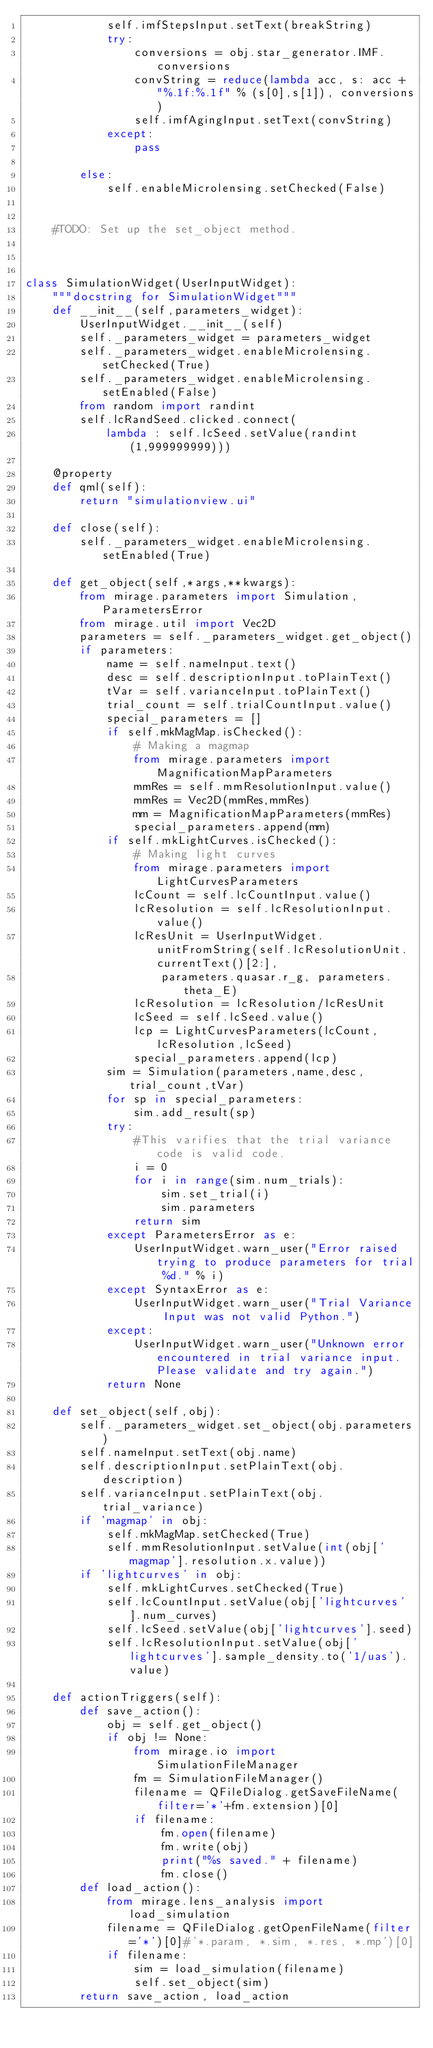Convert code to text. <code><loc_0><loc_0><loc_500><loc_500><_Python_>            self.imfStepsInput.setText(breakString)
            try:
                conversions = obj.star_generator.IMF.conversions
                convString = reduce(lambda acc, s: acc + "%.1f:%.1f" % (s[0],s[1]), conversions)
                self.imfAgingInput.setText(convString)
            except:
                pass

        else:
            self.enableMicrolensing.setChecked(False)


    #TODO: Set up the set_object method.



class SimulationWidget(UserInputWidget):
    """docstring for SimulationWidget"""
    def __init__(self,parameters_widget):
        UserInputWidget.__init__(self)
        self._parameters_widget = parameters_widget
        self._parameters_widget.enableMicrolensing.setChecked(True)
        self._parameters_widget.enableMicrolensing.setEnabled(False)
        from random import randint
        self.lcRandSeed.clicked.connect(
            lambda : self.lcSeed.setValue(randint(1,999999999)))

    @property
    def qml(self):
        return "simulationview.ui"

    def close(self):
        self._parameters_widget.enableMicrolensing.setEnabled(True)

    def get_object(self,*args,**kwargs):
        from mirage.parameters import Simulation, ParametersError
        from mirage.util import Vec2D
        parameters = self._parameters_widget.get_object()
        if parameters:
            name = self.nameInput.text()
            desc = self.descriptionInput.toPlainText()
            tVar = self.varianceInput.toPlainText()
            trial_count = self.trialCountInput.value()
            special_parameters = []
            if self.mkMagMap.isChecked():
                # Making a magmap
                from mirage.parameters import MagnificationMapParameters
                mmRes = self.mmResolutionInput.value()
                mmRes = Vec2D(mmRes,mmRes)
                mm = MagnificationMapParameters(mmRes)
                special_parameters.append(mm)
            if self.mkLightCurves.isChecked():
                # Making light curves
                from mirage.parameters import LightCurvesParameters
                lcCount = self.lcCountInput.value()
                lcResolution = self.lcResolutionInput.value()
                lcResUnit = UserInputWidget.unitFromString(self.lcResolutionUnit.currentText()[2:],
                    parameters.quasar.r_g, parameters.theta_E)
                lcResolution = lcResolution/lcResUnit
                lcSeed = self.lcSeed.value()
                lcp = LightCurvesParameters(lcCount,lcResolution,lcSeed)
                special_parameters.append(lcp)
            sim = Simulation(parameters,name,desc,trial_count,tVar)
            for sp in special_parameters:
                sim.add_result(sp)
            try:
                #This varifies that the trial variance code is valid code.
                i = 0
                for i in range(sim.num_trials):
                    sim.set_trial(i)
                    sim.parameters
                return sim
            except ParametersError as e:
                UserInputWidget.warn_user("Error raised trying to produce parameters for trial %d." % i)
            except SyntaxError as e:
                UserInputWidget.warn_user("Trial Variance Input was not valid Python.")
            except:
                UserInputWidget.warn_user("Unknown error encountered in trial variance input. Please validate and try again.")
            return None

    def set_object(self,obj):
        self._parameters_widget.set_object(obj.parameters)
        self.nameInput.setText(obj.name)
        self.descriptionInput.setPlainText(obj.description)
        self.varianceInput.setPlainText(obj.trial_variance)
        if 'magmap' in obj:
            self.mkMagMap.setChecked(True)
            self.mmResolutionInput.setValue(int(obj['magmap'].resolution.x.value))
        if 'lightcurves' in obj:
            self.mkLightCurves.setChecked(True)
            self.lcCountInput.setValue(obj['lightcurves'].num_curves)
            self.lcSeed.setValue(obj['lightcurves'].seed)
            self.lcResolutionInput.setValue(obj['lightcurves'].sample_density.to('1/uas').value)

    def actionTriggers(self):
        def save_action():
            obj = self.get_object()
            if obj != None:
                from mirage.io import SimulationFileManager
                fm = SimulationFileManager()
                filename = QFileDialog.getSaveFileName(filter='*'+fm.extension)[0]
                if filename:
                    fm.open(filename)
                    fm.write(obj)
                    print("%s saved." + filename)
                    fm.close()
        def load_action():
            from mirage.lens_analysis import load_simulation
            filename = QFileDialog.getOpenFileName(filter='*')[0]#'*.param, *.sim, *.res, *.mp')[0]
            if filename:
                sim = load_simulation(filename)
                self.set_object(sim)
        return save_action, load_action

</code> 